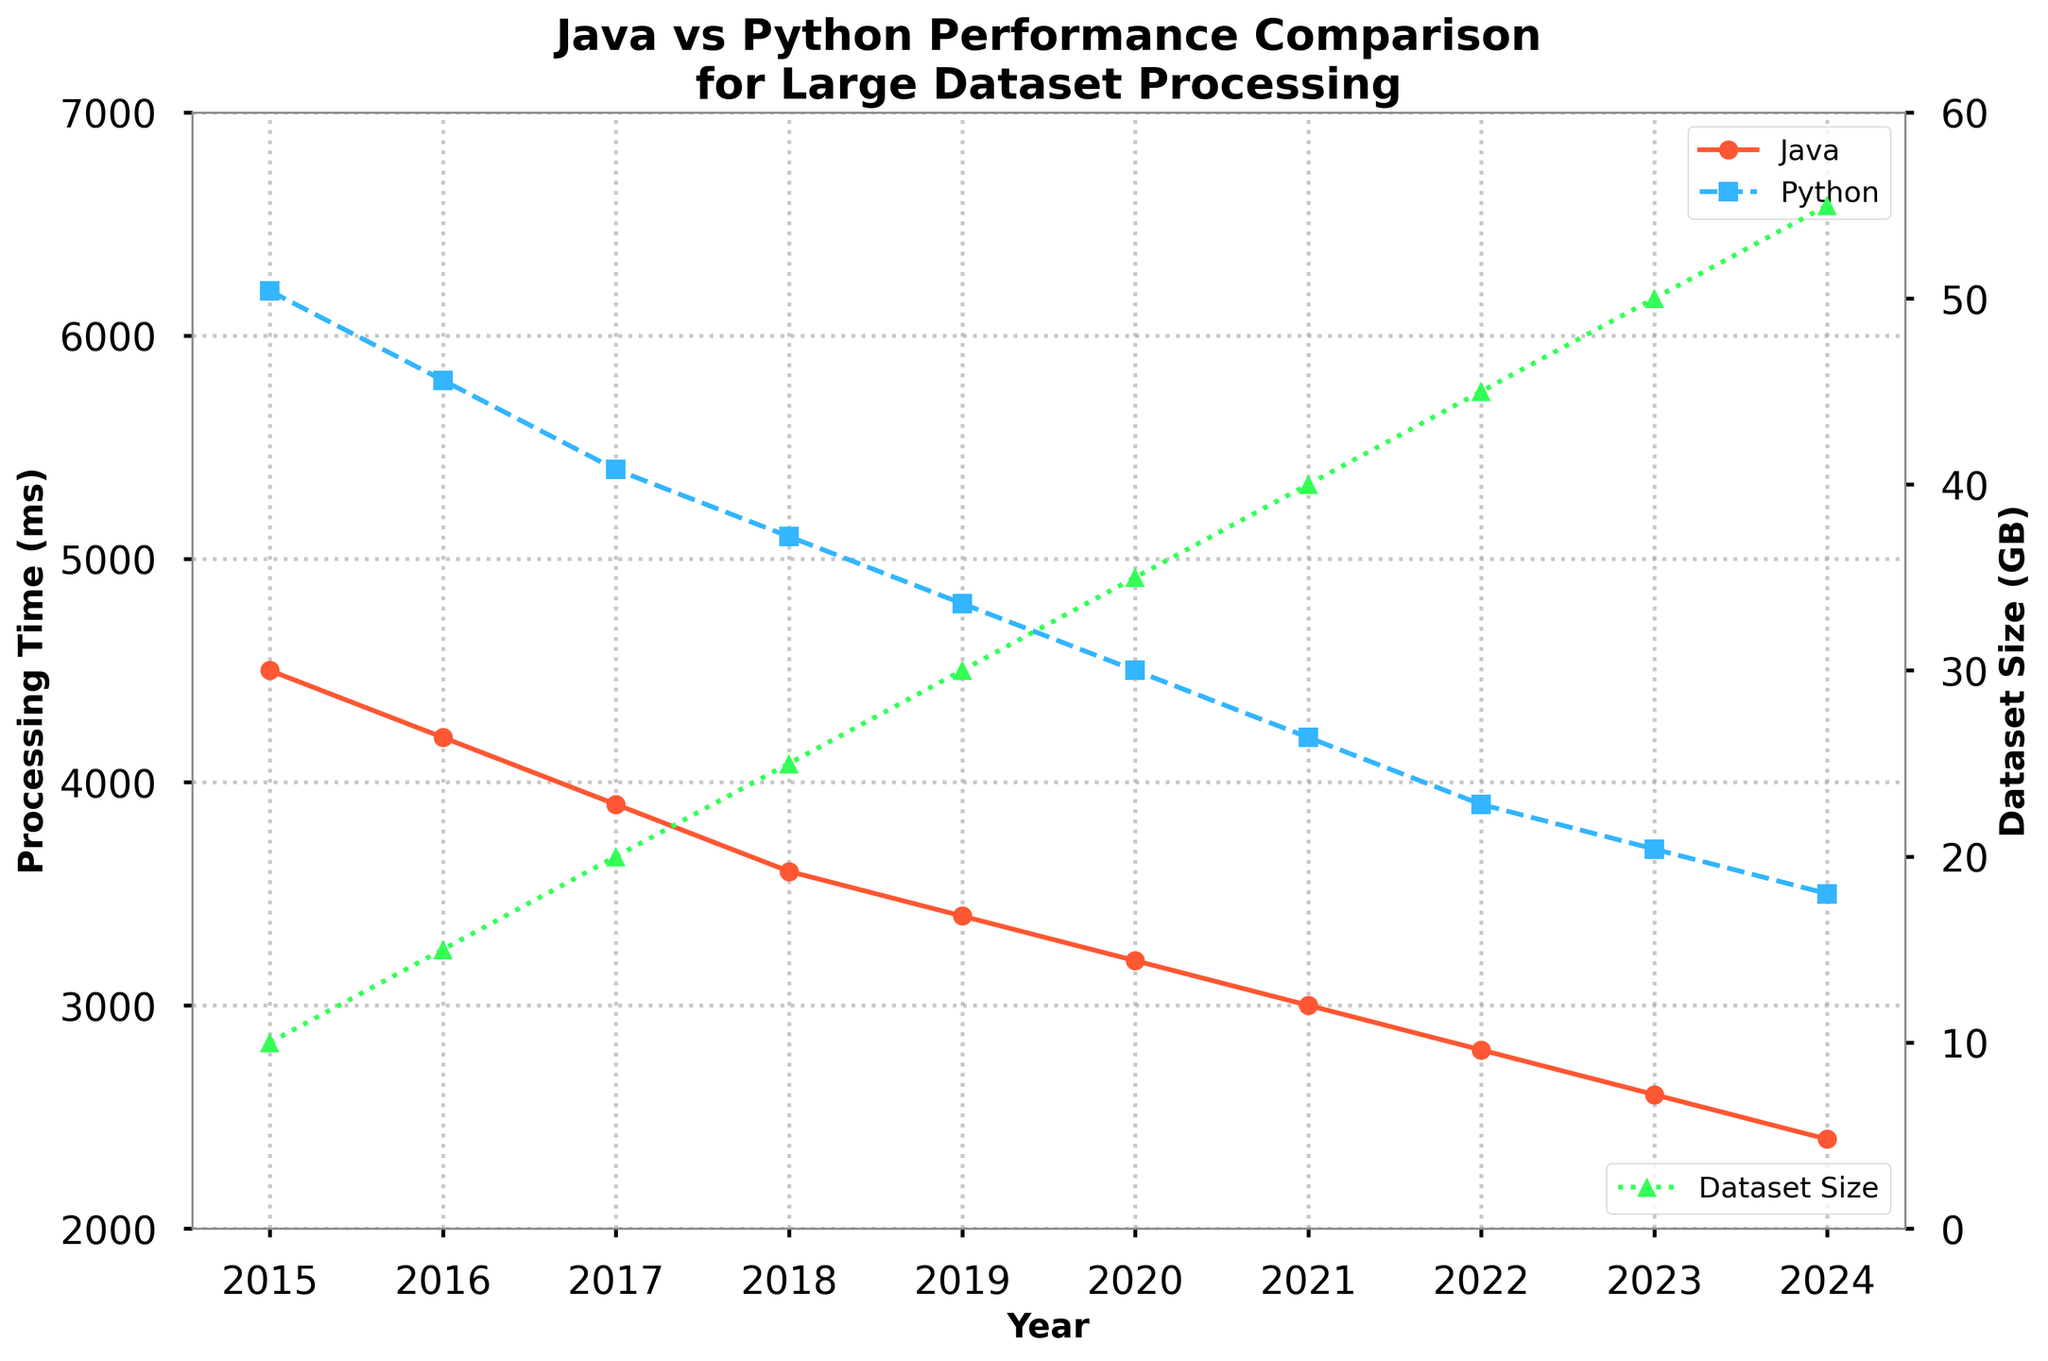What trend in processing time do we see for Java from 2015 to 2024? By observing the line representing Java's processing time on the left y-axis, we notice the processing time steadily decreases every year from 4500 ms in 2015 to 2400 ms in 2024.
Answer: A steady decrease How does Python's processing time in 2018 compare to Java's processing time in the same year? In 2018, Python's processing time is marked at 5100 ms, while Java's processing time is at 3600 ms. It can be observed that Python's processing time is 1500 ms longer than Java's.
Answer: Python's is higher by 1500 ms What is the overall trend of the Dataset Size from 2015 to 2024? Looking at the right y-axis and the green line, the Dataset Size increases consistently from 10 GB in 2015 to 55 GB in 2024.
Answer: Consistent increase Between which years did Java see the most significant drop in processing time? To find the most significant drop, we look for the steepest decline in the Java processing time line. Between 2019 and 2020, the processing time drops from 3400 ms to 3200 ms, which is the largest decline.
Answer: 2019 to 2020 In which year did both Java and Python show the lowest processing time values recorded in the data? The lowest processing time for both Java and Python occurs in the last year of the data, which is 2024. The values are 2400 ms for Java and 3500 ms for Python.
Answer: 2024 What is the difference between the processing times in 2015 for Java and Python? In 2015, Java's processing time is 4500 ms, and Python's is 6200 ms. The difference between their processing times is 6200 ms - 4500 ms, which equals 1700 ms.
Answer: 1700 ms How do the processing times for Java and Python compare in 2022? In 2022, Java's processing time is 2800 ms, and Python's processing time is 3900 ms. Thus, Python's processing time is 1100 ms higher than Java's processing time.
Answer: Python's is higher by 1100 ms What color represents the Dataset Size, and what is its trend? The Dataset Size is represented by the green line. This green line indicates a consistent upward trend from 10 GB in 2015 to 55 GB in 2024.
Answer: Green, consistent increase Which year shows the least difference between Java and Python's processing times? To identify the year with the least difference, compare the y-values of Java and Python for each year. In 2024, Java's processing time is 2400 ms and Python's is 3500 ms, showing a difference of 1100 ms, the smallest in the dataset.
Answer: 2024 